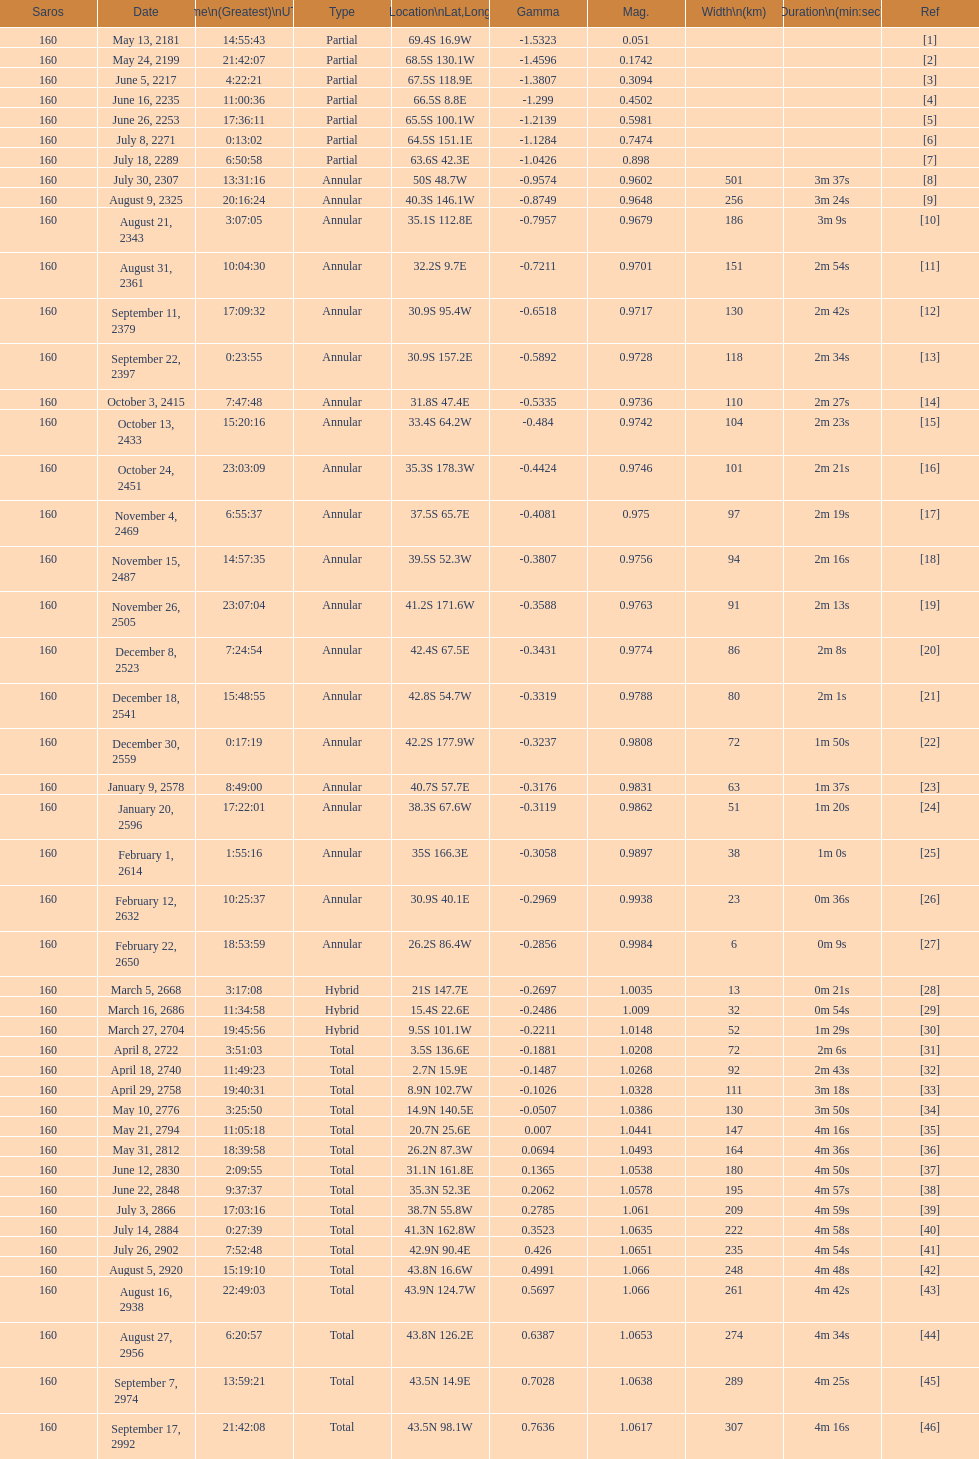Which one has a larger width, 8 or 21? 8. 